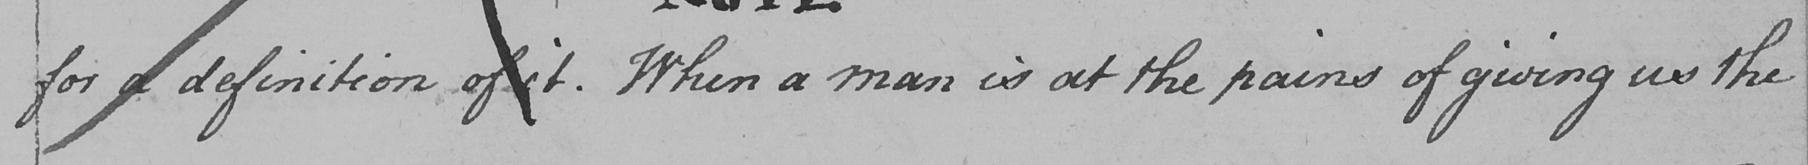What text is written in this handwritten line? for a definition of it . When a man is at the pains of giving us the 